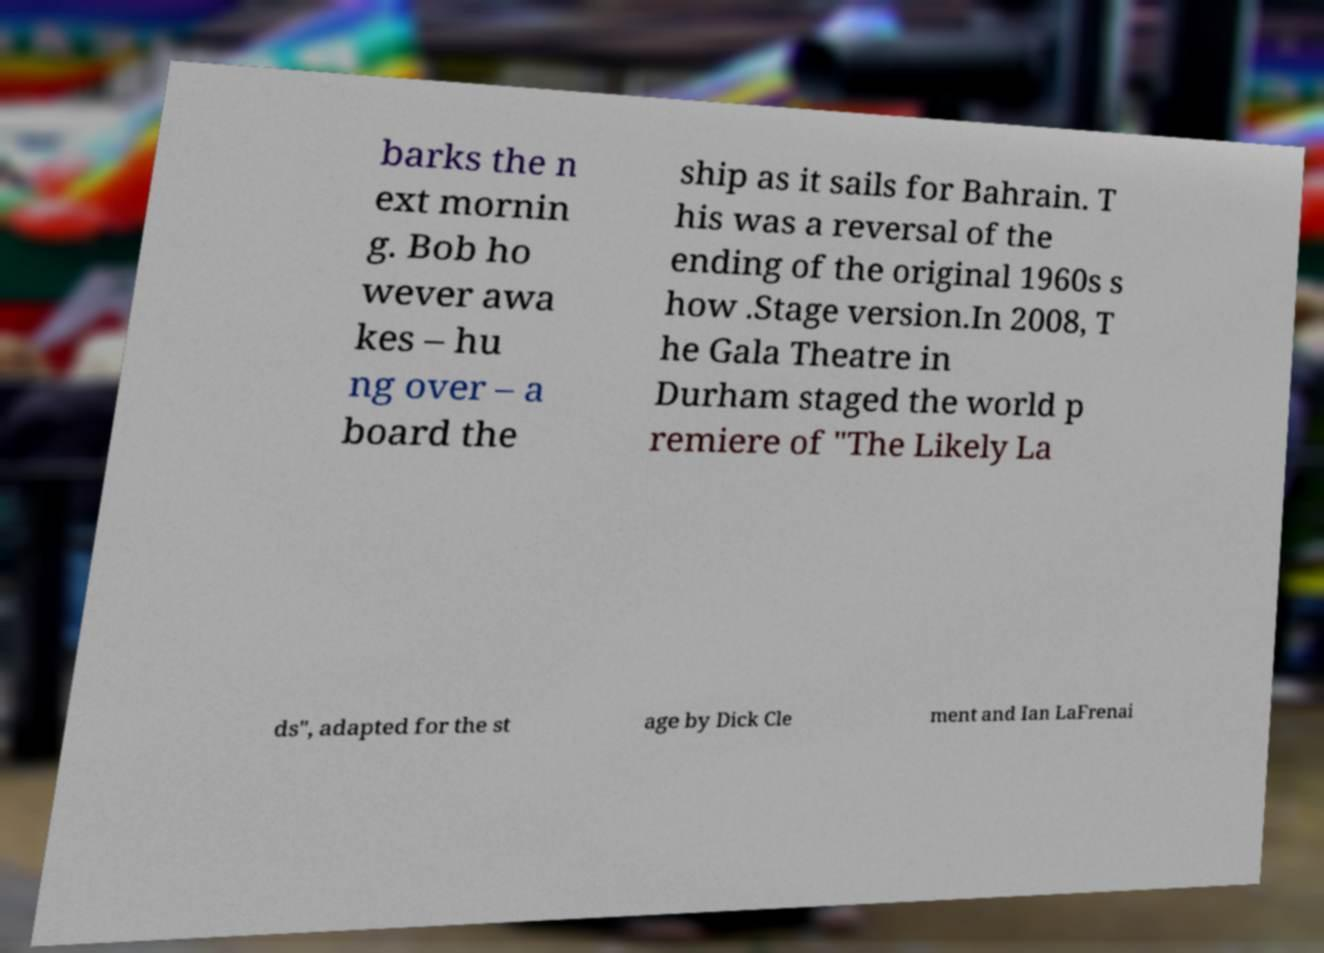Please read and relay the text visible in this image. What does it say? barks the n ext mornin g. Bob ho wever awa kes – hu ng over – a board the ship as it sails for Bahrain. T his was a reversal of the ending of the original 1960s s how .Stage version.In 2008, T he Gala Theatre in Durham staged the world p remiere of "The Likely La ds", adapted for the st age by Dick Cle ment and Ian LaFrenai 